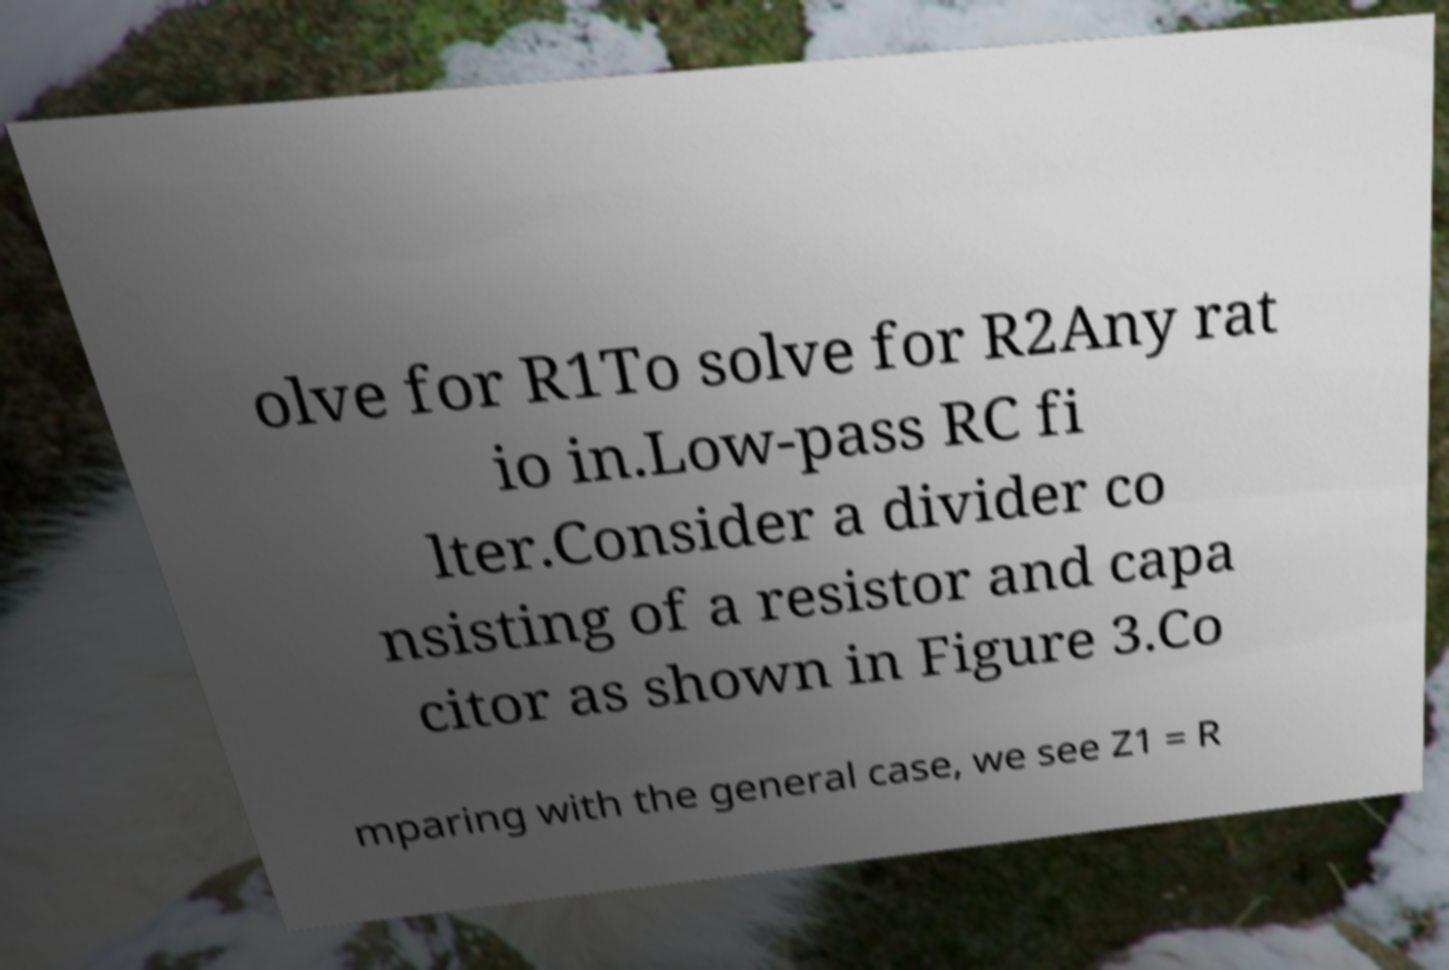Could you assist in decoding the text presented in this image and type it out clearly? olve for R1To solve for R2Any rat io in.Low-pass RC fi lter.Consider a divider co nsisting of a resistor and capa citor as shown in Figure 3.Co mparing with the general case, we see Z1 = R 